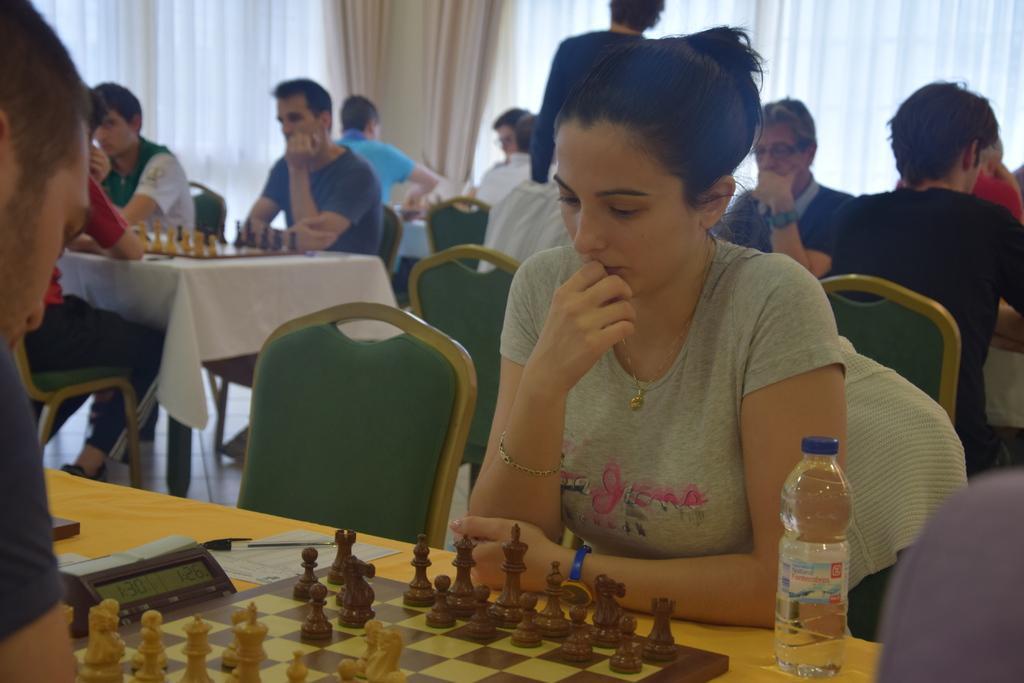Please provide a concise description of this image. This is a picture taken in a room, there are a group of people sitting on a chair and playing the chess game in front of the people there is a table on the table there is a chess board and chess coins and bottle. Background of this people there are curtains which is in white color. 